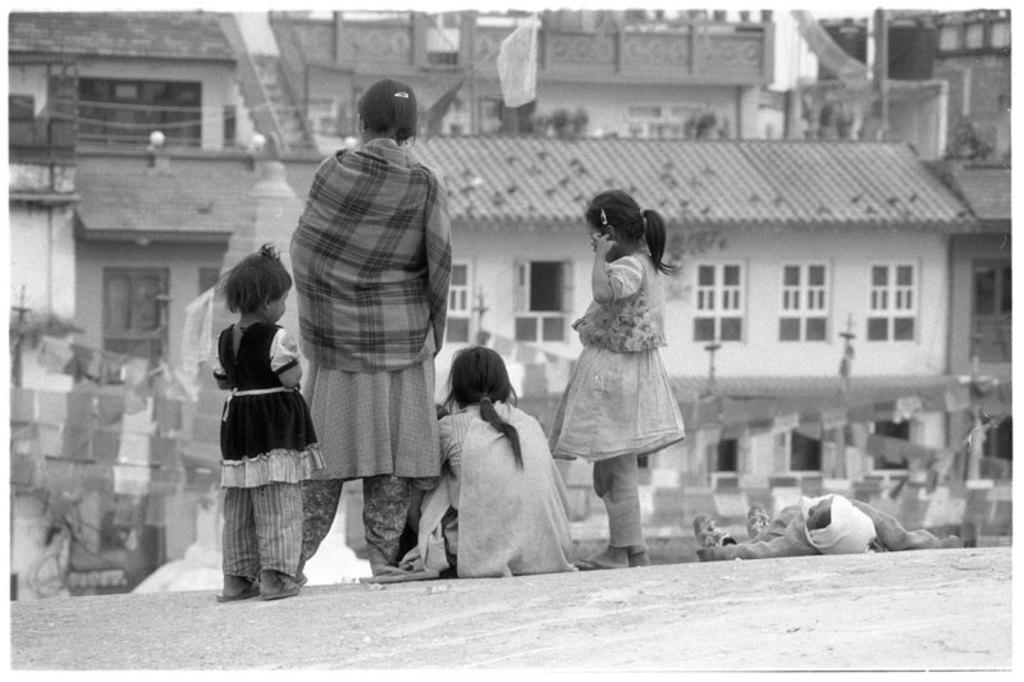What is the position of the woman in the image? There is a woman sitting on the floor in the image. What is the position of the person in the image? There is a person lying on the floor in the image. How many girls are standing in the image? Two girls are standing in the image. How many women are standing in the image? One woman is standing in the image. What can be seen in the background of the image? There are buildings visible in the background of the image. What type of control can be seen in the hands of the person lying on the floor? There is no control visible in the hands of the person lying on the floor in the image. What color is the bottle held by the woman standing in the image? There is no bottle present in the image. 